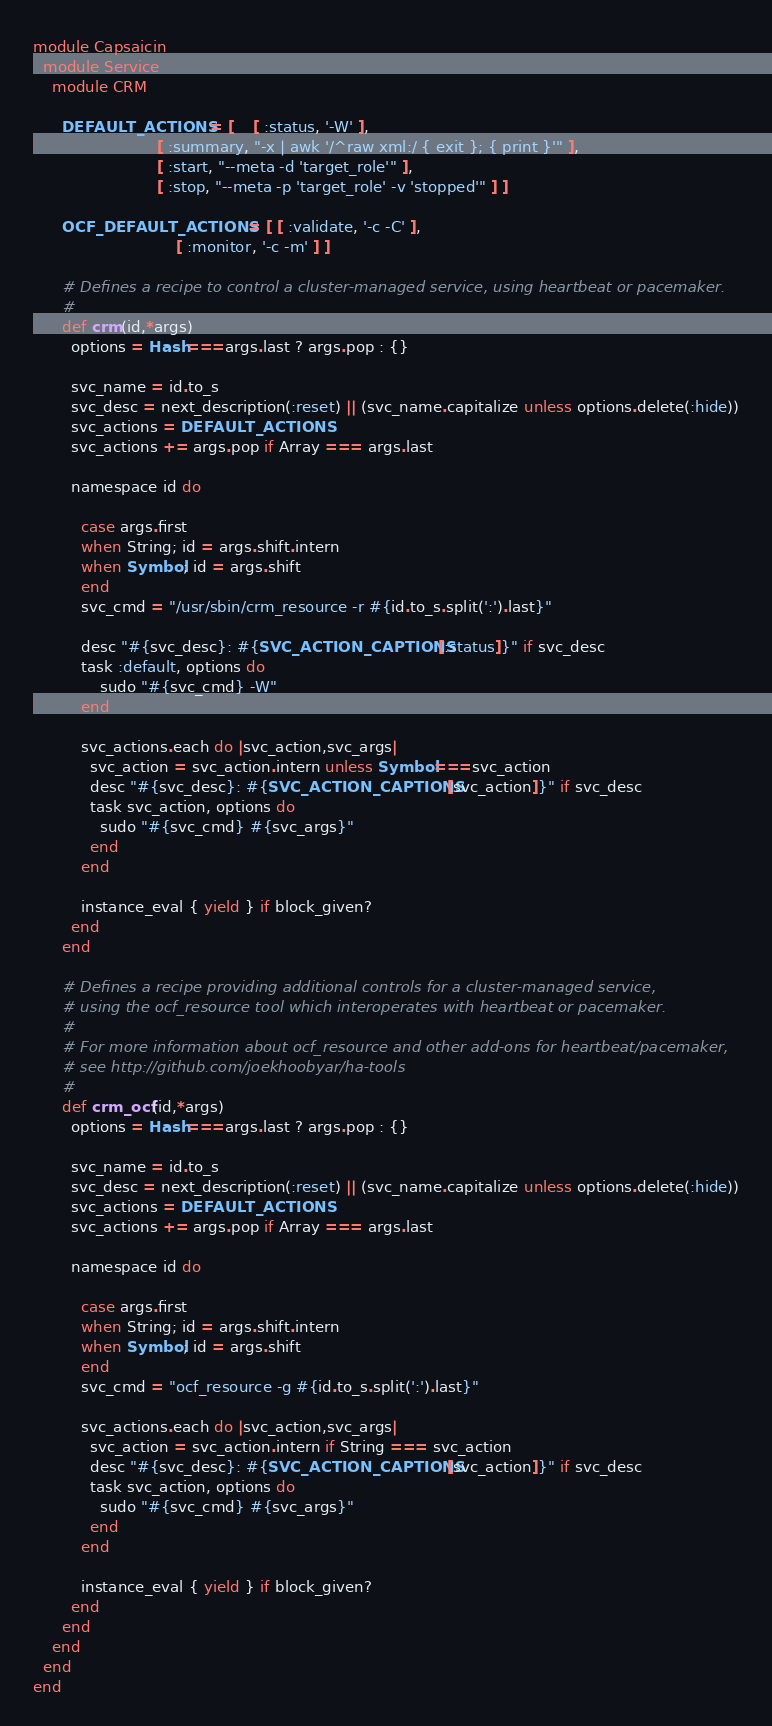Convert code to text. <code><loc_0><loc_0><loc_500><loc_500><_Ruby_>module Capsaicin
  module Service
    module CRM

      DEFAULT_ACTIONS = [	[ :status, '-W' ],
                          [ :summary, "-x | awk '/^raw xml:/ { exit }; { print }'" ],
                          [ :start, "--meta -d 'target_role'" ],
                          [ :stop, "--meta -p 'target_role' -v 'stopped'" ] ]

      OCF_DEFAULT_ACTIONS = [ [ :validate, '-c -C' ],
                              [ :monitor, '-c -m' ] ]

      # Defines a recipe to control a cluster-managed service, using heartbeat or pacemaker.
      #
      def crm(id,*args)
        options = Hash===args.last ? args.pop : {}

        svc_name = id.to_s
        svc_desc = next_description(:reset) || (svc_name.capitalize unless options.delete(:hide))
        svc_actions = DEFAULT_ACTIONS 
        svc_actions += args.pop if Array === args.last

        namespace id do

          case args.first
          when String; id = args.shift.intern
          when Symbol; id = args.shift
          end
          svc_cmd = "/usr/sbin/crm_resource -r #{id.to_s.split(':').last}"

          desc "#{svc_desc}: #{SVC_ACTION_CAPTIONS[:status]}" if svc_desc
          task :default, options do
              sudo "#{svc_cmd} -W"
          end

          svc_actions.each do |svc_action,svc_args|
            svc_action = svc_action.intern unless Symbol===svc_action
            desc "#{svc_desc}: #{SVC_ACTION_CAPTIONS[svc_action]}" if svc_desc
            task svc_action, options do
              sudo "#{svc_cmd} #{svc_args}"
            end
          end

          instance_eval { yield } if block_given?
        end
      end

      # Defines a recipe providing additional controls for a cluster-managed service, 
      # using the ocf_resource tool which interoperates with heartbeat or pacemaker.
      #
      # For more information about ocf_resource and other add-ons for heartbeat/pacemaker,
      # see http://github.com/joekhoobyar/ha-tools
      #
      def crm_ocf(id,*args)
        options = Hash===args.last ? args.pop : {}

        svc_name = id.to_s
        svc_desc = next_description(:reset) || (svc_name.capitalize unless options.delete(:hide))
        svc_actions = DEFAULT_ACTIONS 
        svc_actions += args.pop if Array === args.last

        namespace id do

          case args.first
          when String; id = args.shift.intern
          when Symbol; id = args.shift
          end
          svc_cmd = "ocf_resource -g #{id.to_s.split(':').last}"

          svc_actions.each do |svc_action,svc_args|
            svc_action = svc_action.intern if String === svc_action
            desc "#{svc_desc}: #{SVC_ACTION_CAPTIONS[svc_action]}" if svc_desc
            task svc_action, options do
              sudo "#{svc_cmd} #{svc_args}"
            end
          end

          instance_eval { yield } if block_given?
        end
      end
    end
  end
end

</code> 